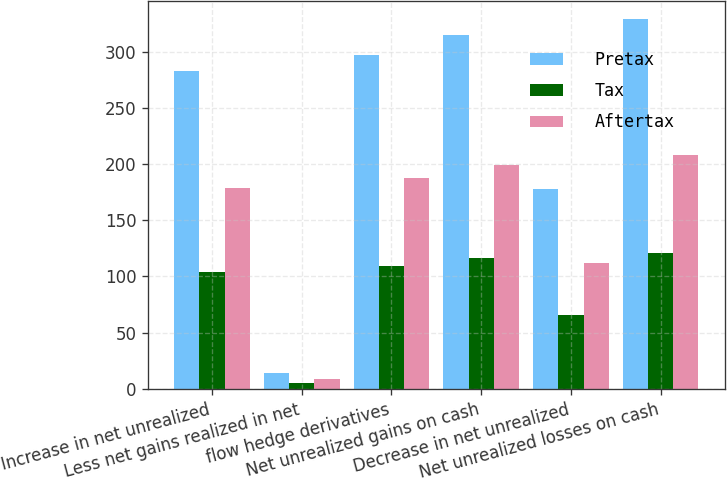Convert chart. <chart><loc_0><loc_0><loc_500><loc_500><stacked_bar_chart><ecel><fcel>Increase in net unrealized<fcel>Less net gains realized in net<fcel>flow hedge derivatives<fcel>Net unrealized gains on cash<fcel>Decrease in net unrealized<fcel>Net unrealized losses on cash<nl><fcel>Pretax<fcel>283<fcel>14<fcel>297<fcel>315<fcel>178<fcel>329<nl><fcel>Tax<fcel>104<fcel>5<fcel>109<fcel>116<fcel>66<fcel>121<nl><fcel>Aftertax<fcel>179<fcel>9<fcel>188<fcel>199<fcel>112<fcel>208<nl></chart> 